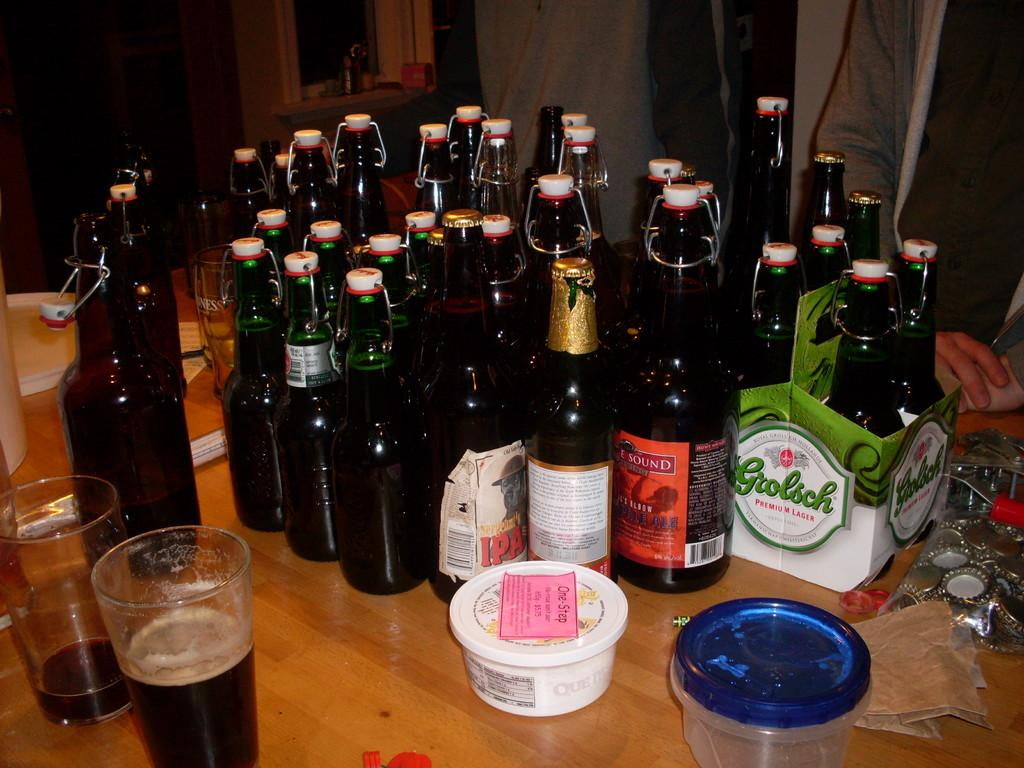Provide a one-sentence caption for the provided image. A table that has a lot of Grosch beer and various other IPA beer. 